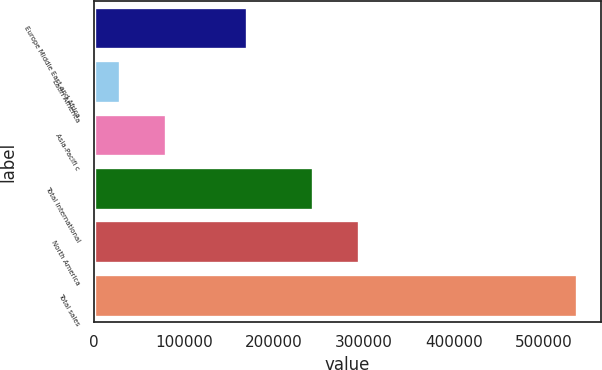<chart> <loc_0><loc_0><loc_500><loc_500><bar_chart><fcel>Europe Middle East and Africa<fcel>Latin America<fcel>Asia-Pacifi c<fcel>Total International<fcel>North America<fcel>Total sales<nl><fcel>170544<fcel>29406<fcel>80105.1<fcel>243854<fcel>294553<fcel>536397<nl></chart> 